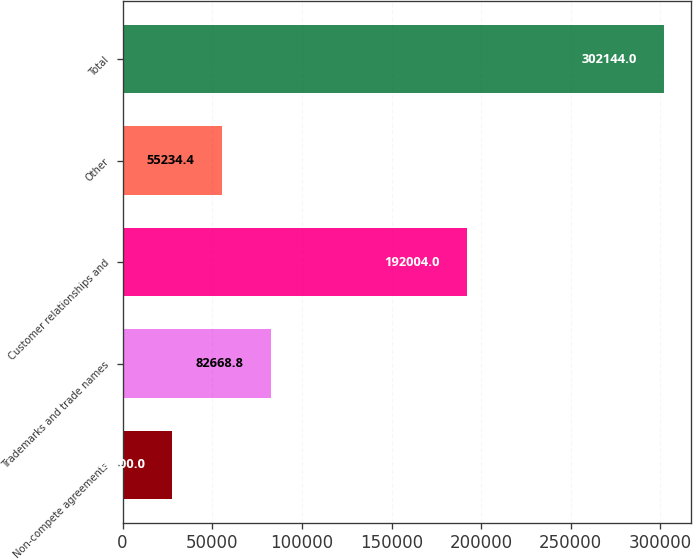<chart> <loc_0><loc_0><loc_500><loc_500><bar_chart><fcel>Non-compete agreements<fcel>Trademarks and trade names<fcel>Customer relationships and<fcel>Other<fcel>Total<nl><fcel>27800<fcel>82668.8<fcel>192004<fcel>55234.4<fcel>302144<nl></chart> 